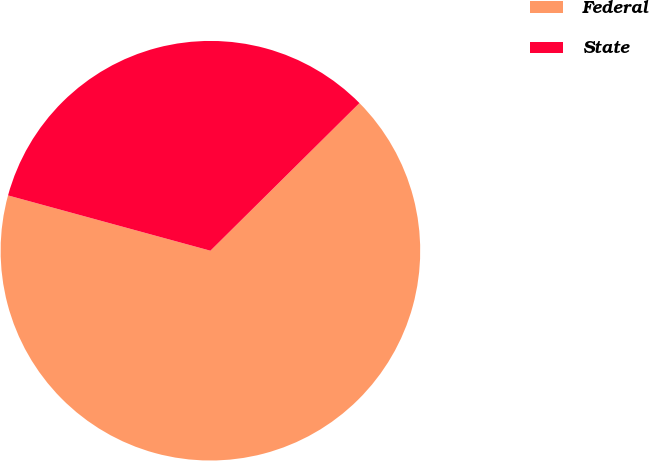Convert chart to OTSL. <chart><loc_0><loc_0><loc_500><loc_500><pie_chart><fcel>Federal<fcel>State<nl><fcel>66.67%<fcel>33.33%<nl></chart> 